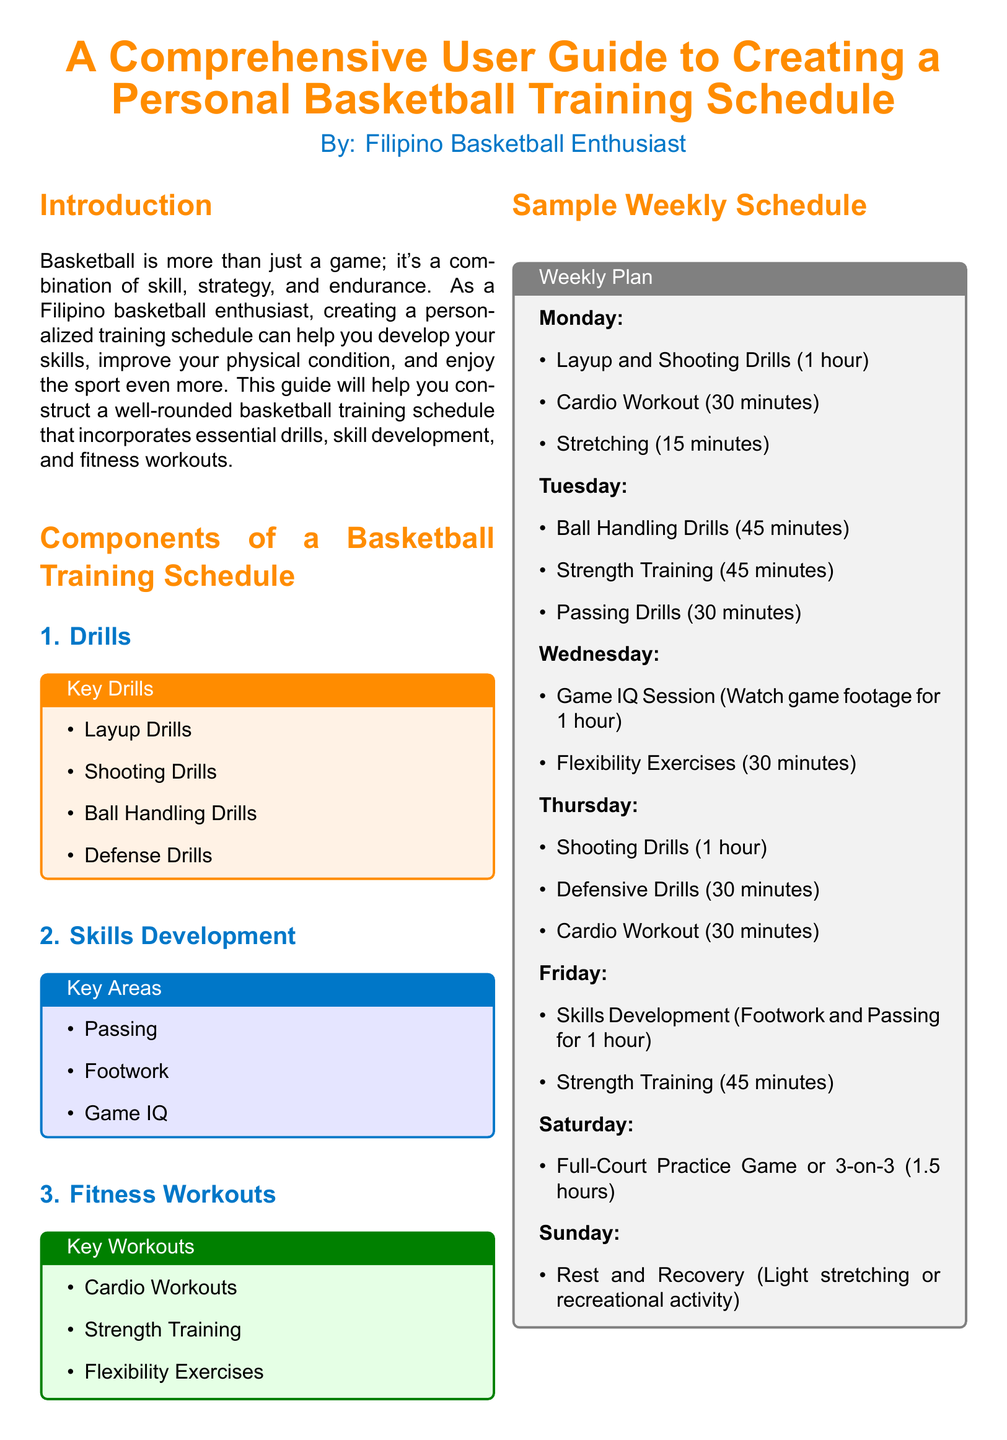What are the key drills mentioned? The key drills are specified in a box and include Layup Drills, Shooting Drills, Ball Handling Drills, and Defense Drills.
Answer: Layup Drills, Shooting Drills, Ball Handling Drills, Defense Drills What day is dedicated to rest and recovery? The schedule indicates that Sunday is set aside for rest and recovery activities.
Answer: Sunday How long is the cardio workout on Monday? The cardio workout's duration is listed in the Monday schedule section as 30 minutes.
Answer: 30 minutes What are the key areas of skills development? Key areas are outlined in a box and include Passing, Footwork, and Game IQ.
Answer: Passing, Footwork, Game IQ How many hours are allocated for the full-court practice game on Saturday? The Saturday schedule specifies that 1.5 hours are designated for this practice.
Answer: 1.5 hours What type of session is planned for Wednesday? The Wednesday schedule includes a Game IQ session where participants watch game footage for improvement.
Answer: Game IQ Session What is the primary focus of Tuesday's training session? The Tuesday training session covers Ball Handling Drills and other activities, manifesting the focus on ball handling skills.
Answer: Ball Handling Drills What color represents the section title for fitness workouts? The title for fitness workouts utilizes a green color specified in the document.
Answer: Green 